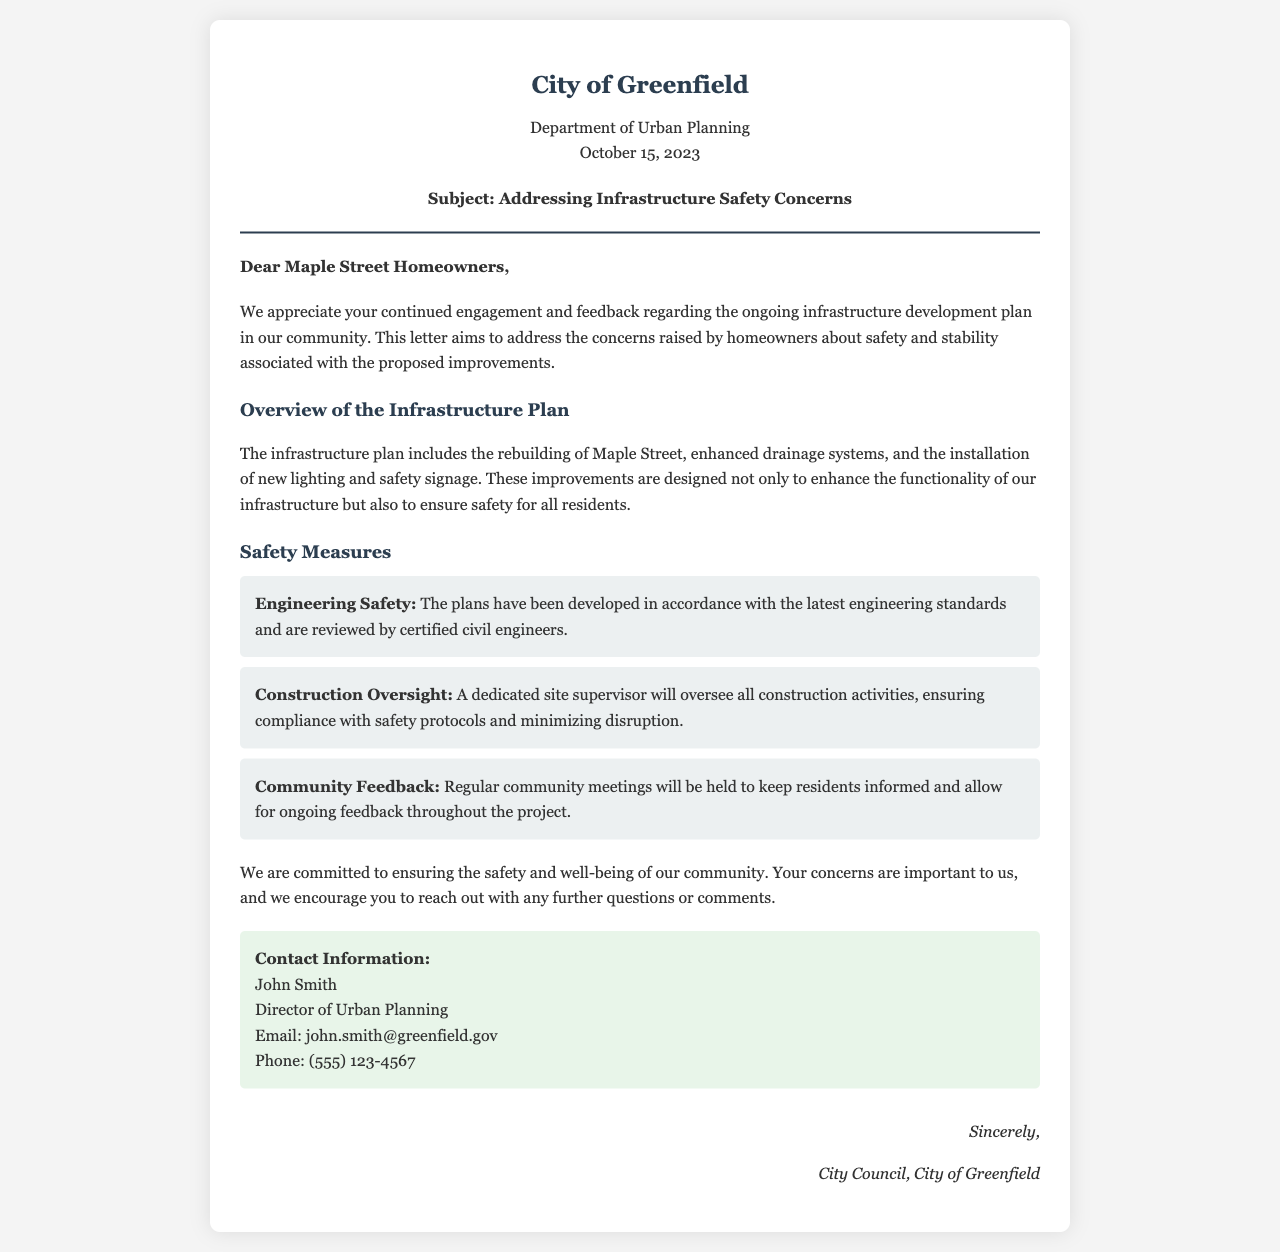what is the date of the letter? The date of the letter is mentioned in the header section, indicating when it was created.
Answer: October 15, 2023 who is the director of urban planning? The document states the name of the person in charge of urban planning, which addresses homeowner concerns.
Answer: John Smith what is one of the improvements included in the infrastructure plan? The letter lists specific improvements that make up the infrastructure development plan.
Answer: Enhanced drainage systems how will construction activities be overseen? The document mentions the method of supervision for construction to ensure safety standards are met.
Answer: A dedicated site supervisor what is the main purpose of the letter? The letter indicates its intent to communicate about safety and stability associated with ongoing infrastructure development.
Answer: Addressing concerns how will homeowners be kept informed during the project? The document describes mechanisms for ongoing communication with the community throughout the project.
Answer: Regular community meetings what is the background color of the contact information section? The letter describes the visual attributes of various sections, including contact information.
Answer: Light green (e8f5e9) who is the intended audience of the letter? The greeting section specifically addresses those who are the recipients of the letter, indicating its audience.
Answer: Maple Street Homeowners what type of letter is this document? The document's structure and content categorize it within a specific context related to urban development and community communication.
Answer: Official letter 